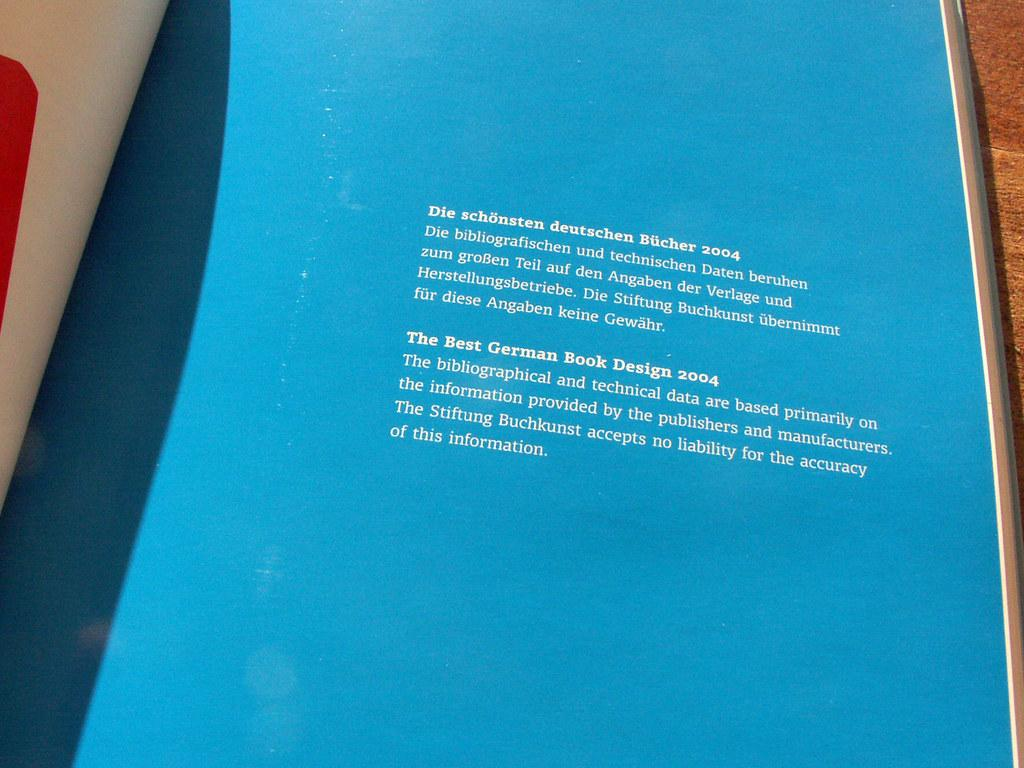<image>
Write a terse but informative summary of the picture. the word die is on front of a blue background 